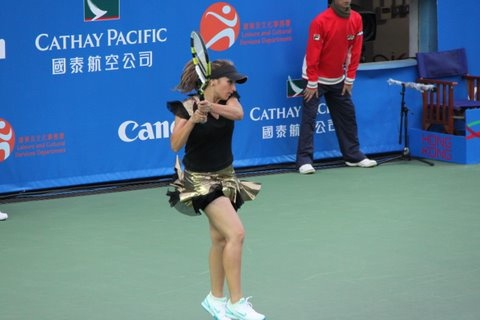Describe the objects in this image and their specific colors. I can see people in blue, black, tan, and gray tones, people in blue, black, brown, and navy tones, chair in blue, navy, black, and maroon tones, and tennis racket in blue, darkgray, black, gray, and lightgray tones in this image. 